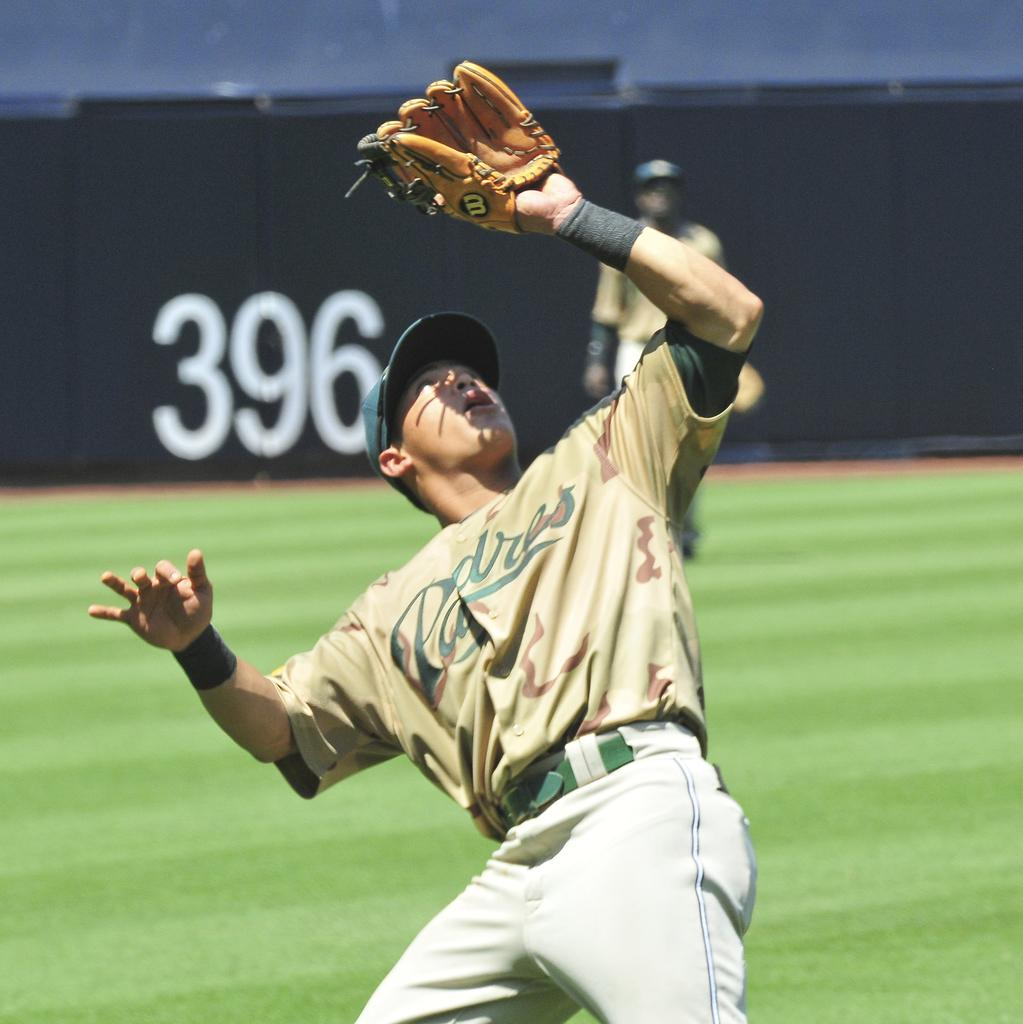Provide a one-sentence caption for the provided image. A baseball player has his glove up on the air and A jersey on that says Padres. 